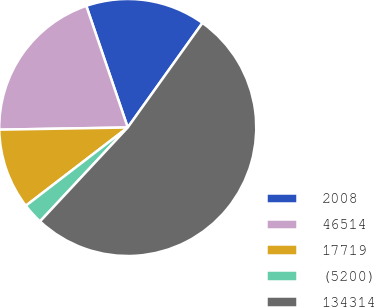Convert chart. <chart><loc_0><loc_0><loc_500><loc_500><pie_chart><fcel>2008<fcel>46514<fcel>17719<fcel>(5200)<fcel>134314<nl><fcel>15.1%<fcel>20.04%<fcel>10.15%<fcel>2.62%<fcel>52.08%<nl></chart> 